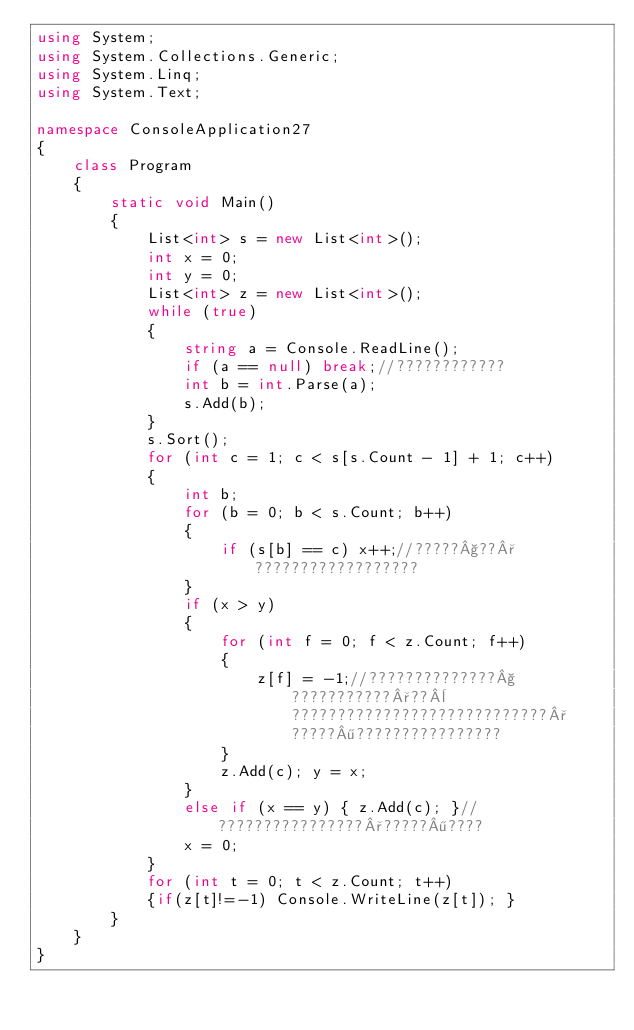<code> <loc_0><loc_0><loc_500><loc_500><_C#_>using System;
using System.Collections.Generic;
using System.Linq;
using System.Text;

namespace ConsoleApplication27
{
    class Program
    {
        static void Main()
        {
            List<int> s = new List<int>();
            int x = 0;
            int y = 0;
            List<int> z = new List<int>();
            while (true)
            {
                string a = Console.ReadLine();
                if (a == null) break;//????????????
                int b = int.Parse(a);
                s.Add(b);
            }
            s.Sort();
            for (int c = 1; c < s[s.Count - 1] + 1; c++)
            {
                int b;
                for (b = 0; b < s.Count; b++)
                {
                    if (s[b] == c) x++;//?????§??°??????????????????
                }
                if (x > y)
                {
                    for (int f = 0; f < z.Count; f++)
                    {
                        z[f] = -1;//??????????????§???????????°??¨????????????????????????????°?????¶????????????????
                    }
                    z.Add(c); y = x;
                }
                else if (x == y) { z.Add(c); }//????????????????°?????¶????
                x = 0;
            }
            for (int t = 0; t < z.Count; t++)
            {if(z[t]!=-1) Console.WriteLine(z[t]); }
        }
    }
}</code> 